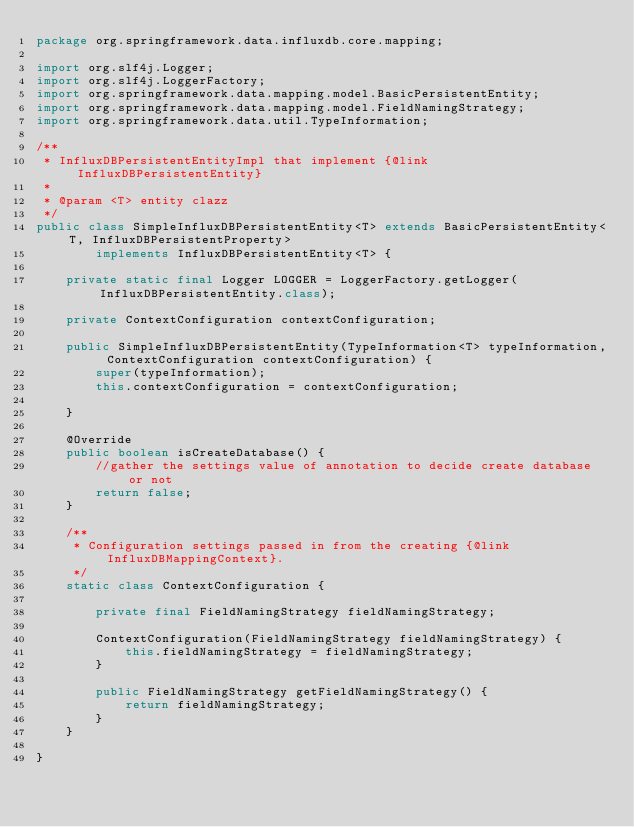<code> <loc_0><loc_0><loc_500><loc_500><_Java_>package org.springframework.data.influxdb.core.mapping;

import org.slf4j.Logger;
import org.slf4j.LoggerFactory;
import org.springframework.data.mapping.model.BasicPersistentEntity;
import org.springframework.data.mapping.model.FieldNamingStrategy;
import org.springframework.data.util.TypeInformation;

/**
 * InfluxDBPersistentEntityImpl that implement {@link InfluxDBPersistentEntity}
 *
 * @param <T> entity clazz
 */
public class SimpleInfluxDBPersistentEntity<T> extends BasicPersistentEntity<T, InfluxDBPersistentProperty>
        implements InfluxDBPersistentEntity<T> {

    private static final Logger LOGGER = LoggerFactory.getLogger(InfluxDBPersistentEntity.class);

    private ContextConfiguration contextConfiguration;

    public SimpleInfluxDBPersistentEntity(TypeInformation<T> typeInformation, ContextConfiguration contextConfiguration) {
        super(typeInformation);
        this.contextConfiguration = contextConfiguration;

    }

    @Override
    public boolean isCreateDatabase() {
        //gather the settings value of annotation to decide create database or not
        return false;
    }

    /**
     * Configuration settings passed in from the creating {@link InfluxDBMappingContext}.
     */
    static class ContextConfiguration {

        private final FieldNamingStrategy fieldNamingStrategy;

        ContextConfiguration(FieldNamingStrategy fieldNamingStrategy) {
            this.fieldNamingStrategy = fieldNamingStrategy;
        }

        public FieldNamingStrategy getFieldNamingStrategy() {
            return fieldNamingStrategy;
        }
    }

}
</code> 